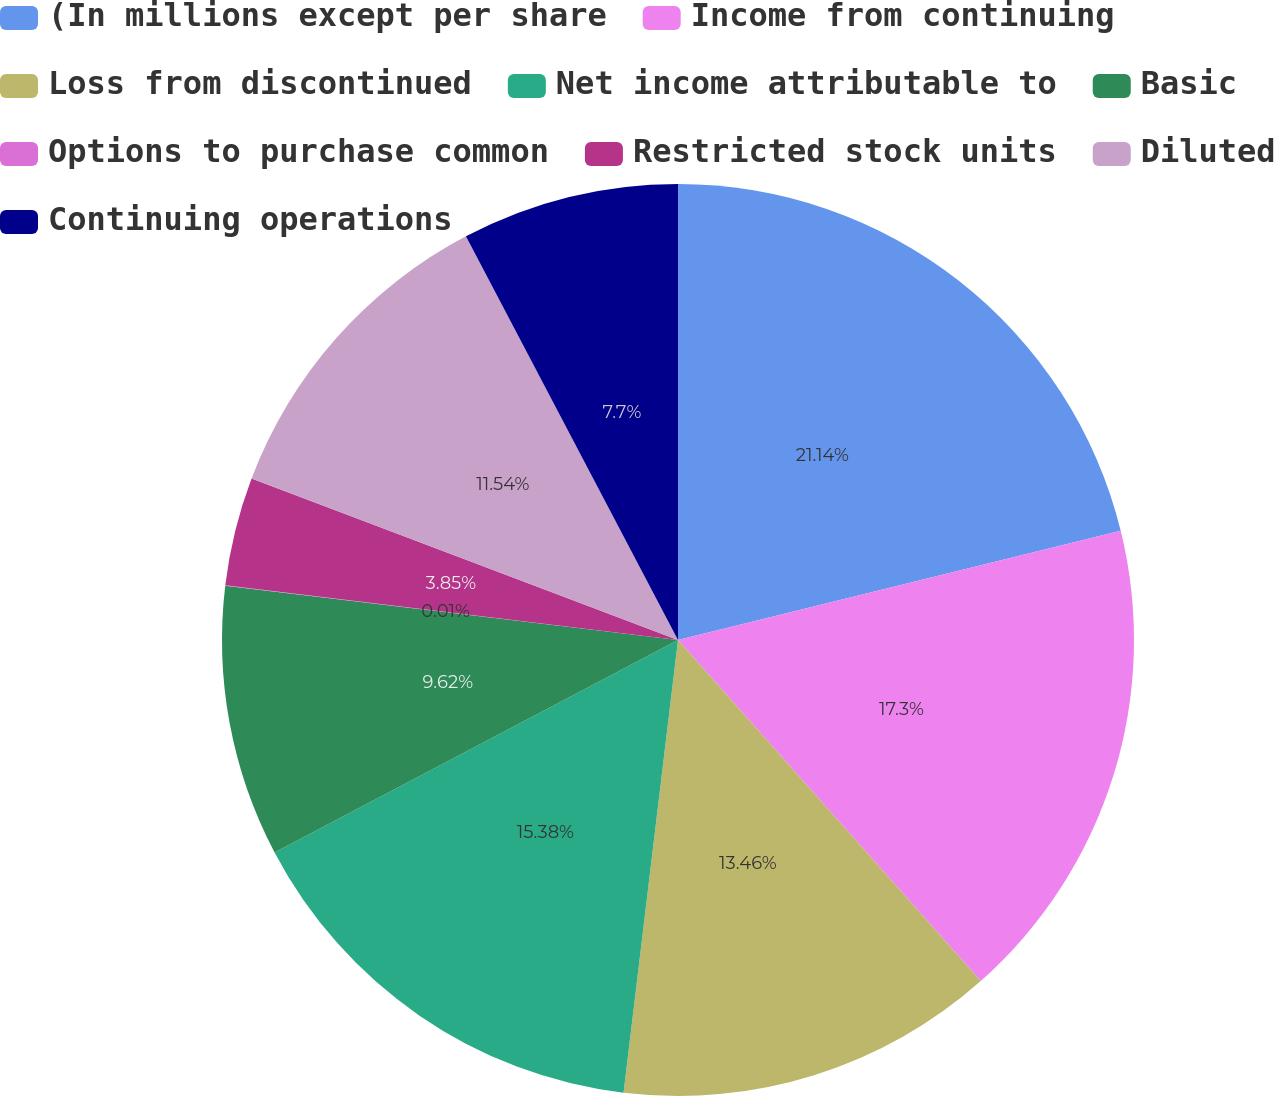Convert chart to OTSL. <chart><loc_0><loc_0><loc_500><loc_500><pie_chart><fcel>(In millions except per share<fcel>Income from continuing<fcel>Loss from discontinued<fcel>Net income attributable to<fcel>Basic<fcel>Options to purchase common<fcel>Restricted stock units<fcel>Diluted<fcel>Continuing operations<nl><fcel>21.15%<fcel>17.3%<fcel>13.46%<fcel>15.38%<fcel>9.62%<fcel>0.01%<fcel>3.85%<fcel>11.54%<fcel>7.7%<nl></chart> 